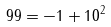Convert formula to latex. <formula><loc_0><loc_0><loc_500><loc_500>9 9 = - 1 + 1 0 ^ { 2 }</formula> 